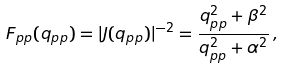Convert formula to latex. <formula><loc_0><loc_0><loc_500><loc_500>F _ { p p } ( q _ { p p } ) = | J ( q _ { p p } ) | ^ { - 2 } = \frac { q _ { p p } ^ { 2 } + \beta ^ { 2 } } { q _ { p p } ^ { 2 } + \alpha ^ { 2 } } \, ,</formula> 